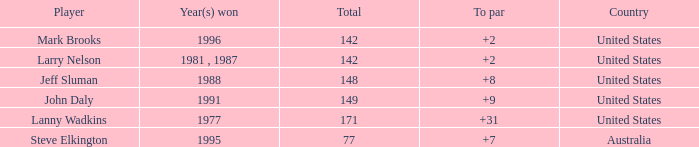Name the Total of australia and a To par smaller than 7? None. 